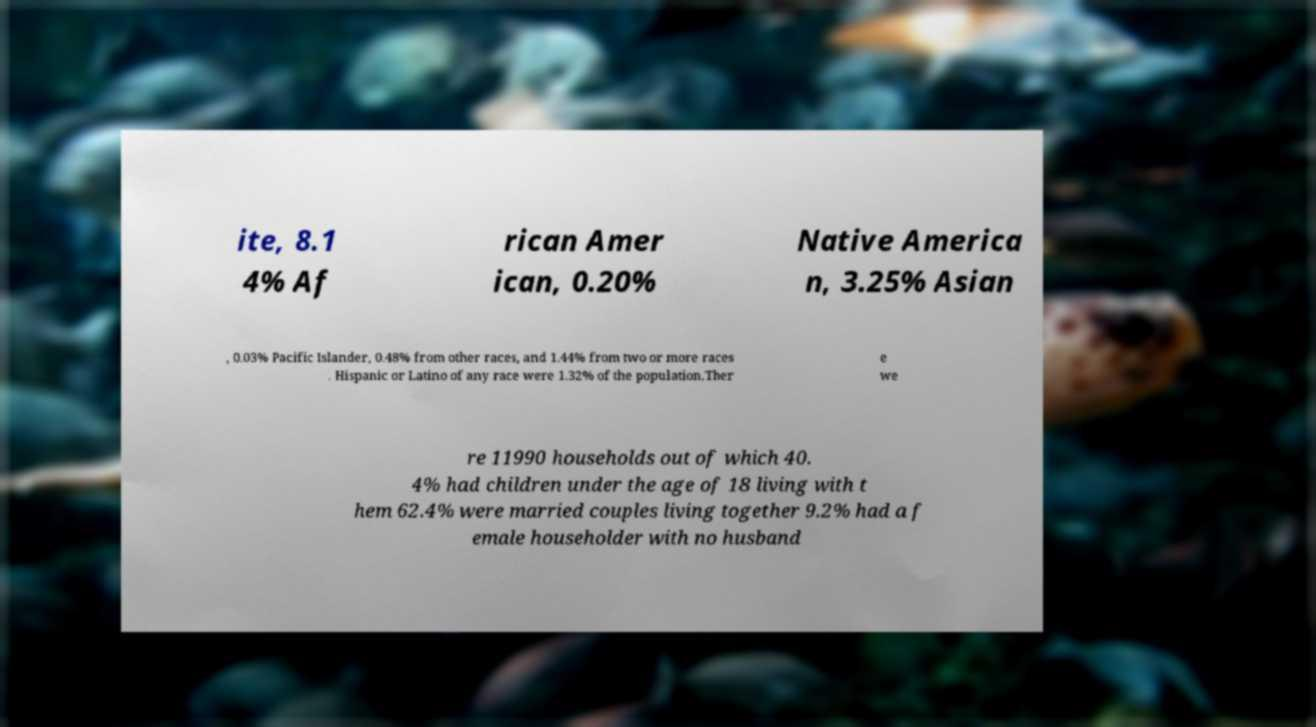Can you accurately transcribe the text from the provided image for me? ite, 8.1 4% Af rican Amer ican, 0.20% Native America n, 3.25% Asian , 0.03% Pacific Islander, 0.48% from other races, and 1.44% from two or more races . Hispanic or Latino of any race were 1.32% of the population.Ther e we re 11990 households out of which 40. 4% had children under the age of 18 living with t hem 62.4% were married couples living together 9.2% had a f emale householder with no husband 